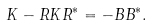Convert formula to latex. <formula><loc_0><loc_0><loc_500><loc_500>K - R K R ^ { * } = - B B ^ { * } .</formula> 